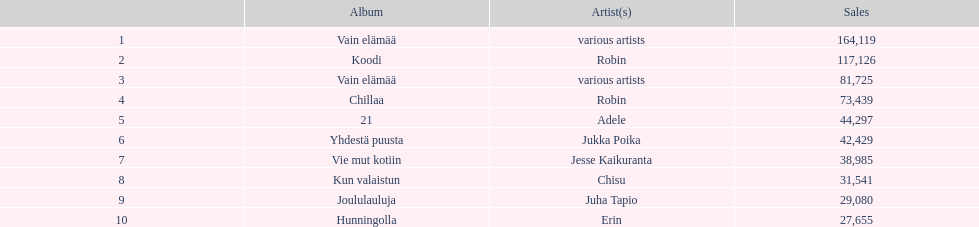How many albums sold for than 50,000 copies this year? 4. Could you parse the entire table? {'header': ['', 'Album', 'Artist(s)', 'Sales'], 'rows': [['1', 'Vain elämää', 'various artists', '164,119'], ['2', 'Koodi', 'Robin', '117,126'], ['3', 'Vain elämää', 'various artists', '81,725'], ['4', 'Chillaa', 'Robin', '73,439'], ['5', '21', 'Adele', '44,297'], ['6', 'Yhdestä puusta', 'Jukka Poika', '42,429'], ['7', 'Vie mut kotiin', 'Jesse Kaikuranta', '38,985'], ['8', 'Kun valaistun', 'Chisu', '31,541'], ['9', 'Joululauluja', 'Juha Tapio', '29,080'], ['10', 'Hunningolla', 'Erin', '27,655']]} 